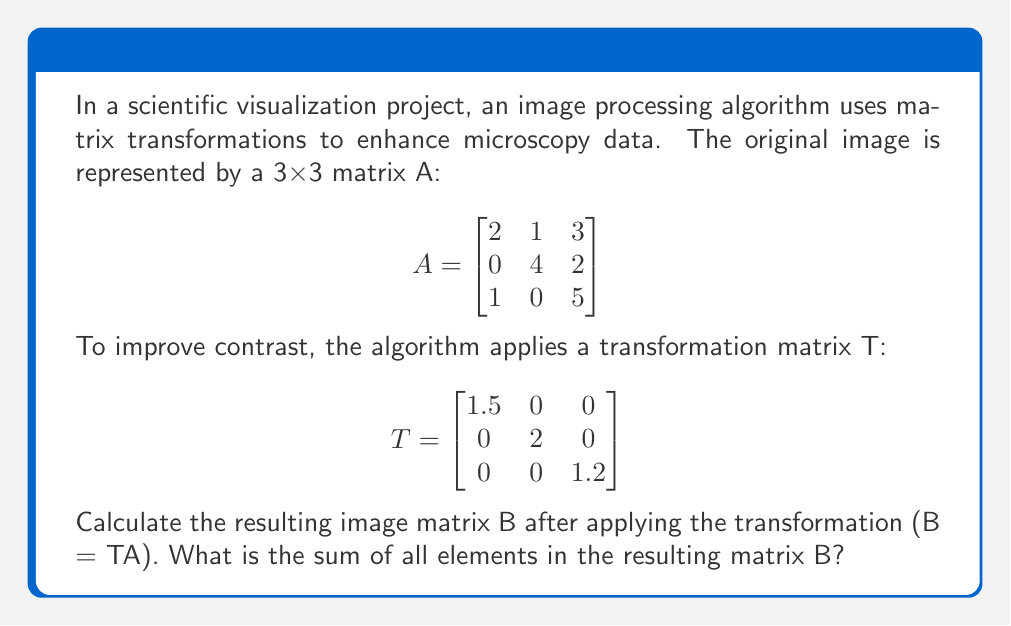Could you help me with this problem? To solve this problem, we need to follow these steps:

1) First, we need to perform matrix multiplication of T and A to get B:

   $$B = TA = \begin{bmatrix}
   1.5 & 0 & 0 \\
   0 & 2 & 0 \\
   0 & 0 & 1.2
   \end{bmatrix} \times \begin{bmatrix}
   2 & 1 & 3 \\
   0 & 4 & 2 \\
   1 & 0 & 5
   \end{bmatrix}$$

2) Calculating each element of B:

   $b_{11} = 1.5(2) + 0(0) + 0(1) = 3$
   $b_{12} = 1.5(1) + 0(4) + 0(0) = 1.5$
   $b_{13} = 1.5(3) + 0(2) + 0(5) = 4.5$
   
   $b_{21} = 0(2) + 2(0) + 0(1) = 0$
   $b_{22} = 0(1) + 2(4) + 0(0) = 8$
   $b_{23} = 0(3) + 2(2) + 0(5) = 4$
   
   $b_{31} = 0(2) + 0(0) + 1.2(1) = 1.2$
   $b_{32} = 0(1) + 0(4) + 1.2(0) = 0$
   $b_{33} = 0(3) + 0(2) + 1.2(5) = 6$

3) Therefore, matrix B is:

   $$B = \begin{bmatrix}
   3 & 1.5 & 4.5 \\
   0 & 8 & 4 \\
   1.2 & 0 & 6
   \end{bmatrix}$$

4) To find the sum of all elements, we add up all entries in B:

   Sum = 3 + 1.5 + 4.5 + 0 + 8 + 4 + 1.2 + 0 + 6 = 28.2
Answer: 28.2 